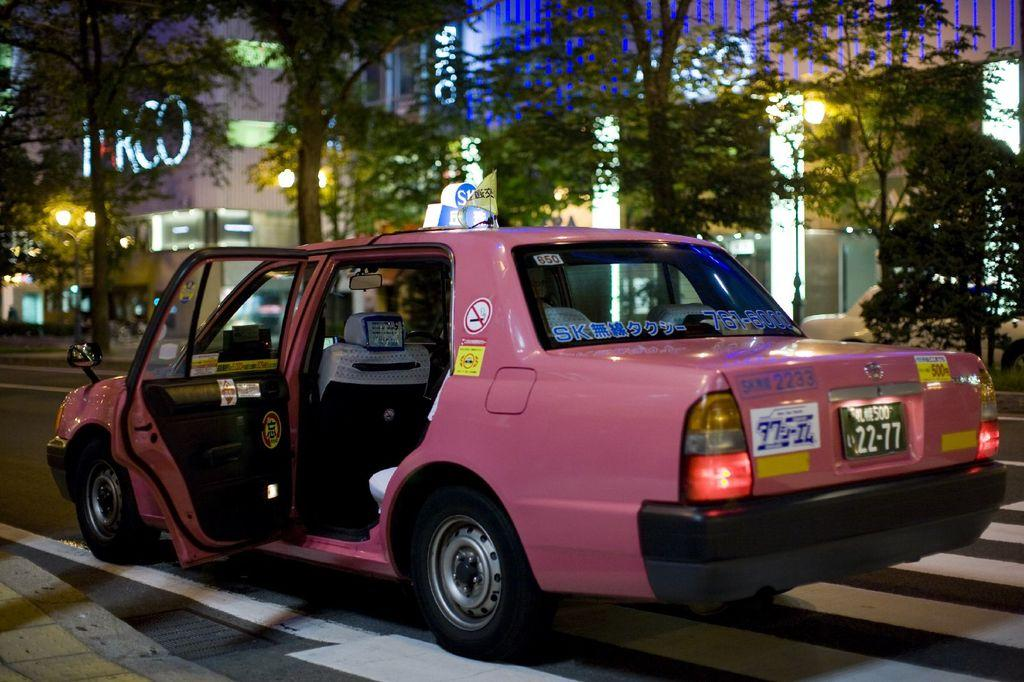What is the main subject of the image? There is a car on the road in the image. What can be seen in the surroundings of the car? There are trees visible in the image. What is visible in the background of the image? There are buildings in the background of the image. What type of ring is the car wearing in the image? There is no ring present in the image, as cars do not wear rings. 